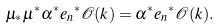<formula> <loc_0><loc_0><loc_500><loc_500>\mu _ { * } \mu ^ { * } \alpha ^ { * } { e _ { n } } ^ { * } { \mathcal { O } } ( k ) = \alpha ^ { * } { e _ { n } } ^ { * } { \mathcal { O } } ( k ) .</formula> 